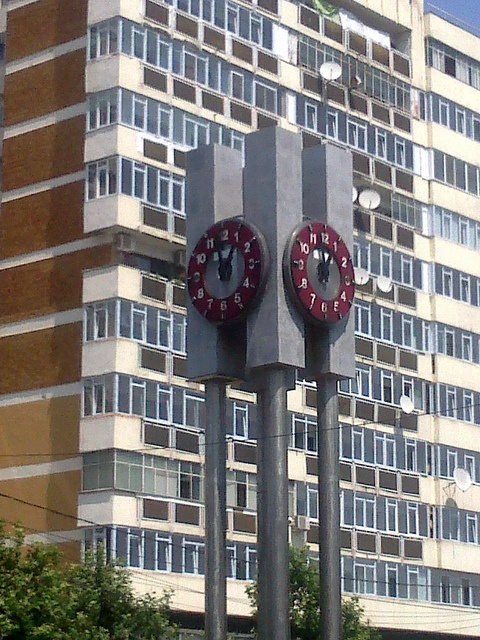Describe the objects in this image and their specific colors. I can see clock in darkgray, black, gray, and darkblue tones and clock in darkgray, gray, purple, and black tones in this image. 